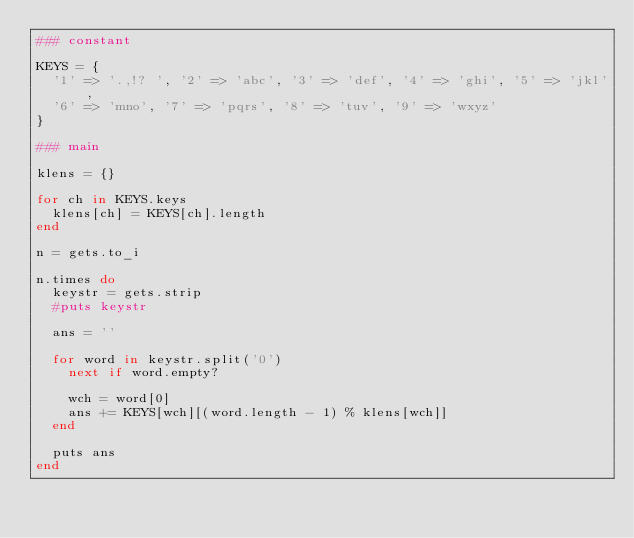Convert code to text. <code><loc_0><loc_0><loc_500><loc_500><_Ruby_>### constant

KEYS = {
  '1' => '.,!? ', '2' => 'abc', '3' => 'def', '4' => 'ghi', '5' => 'jkl',
  '6' => 'mno', '7' => 'pqrs', '8' => 'tuv', '9' => 'wxyz'
}

### main

klens = {}

for ch in KEYS.keys
  klens[ch] = KEYS[ch].length
end

n = gets.to_i

n.times do
  keystr = gets.strip
  #puts keystr

  ans = ''
  
  for word in keystr.split('0')
    next if word.empty?

    wch = word[0]
    ans += KEYS[wch][(word.length - 1) % klens[wch]]
  end

  puts ans
end</code> 